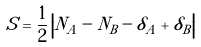Convert formula to latex. <formula><loc_0><loc_0><loc_500><loc_500>S = \frac { 1 } { 2 } \left | N _ { A } - N _ { B } - \delta _ { A } + \delta _ { B } \right |</formula> 